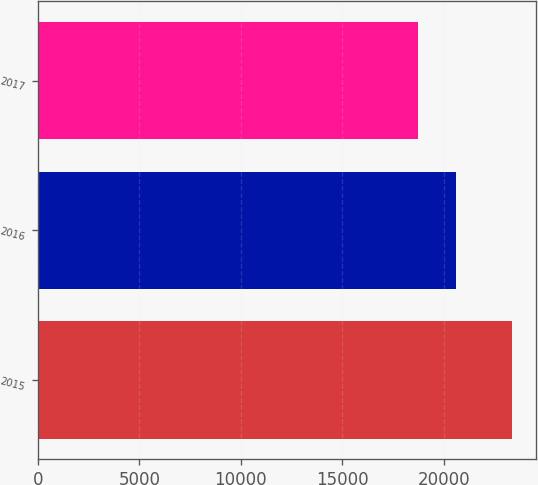<chart> <loc_0><loc_0><loc_500><loc_500><bar_chart><fcel>2015<fcel>2016<fcel>2017<nl><fcel>23377<fcel>20621<fcel>18744<nl></chart> 